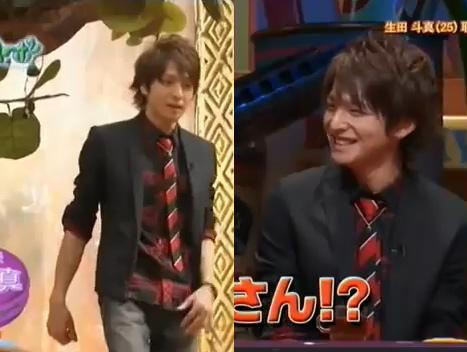Where would the contents of this image probably be seen exactly assis?

Choices:
A) on floor
B) in person
C) on painting
D) on tv on tv 